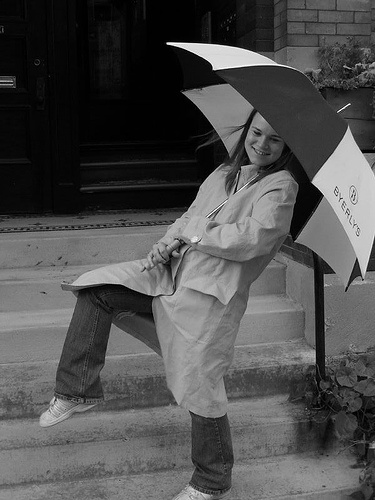Describe the objects in this image and their specific colors. I can see people in black, darkgray, gray, and lightgray tones and umbrella in black, lightgray, and gray tones in this image. 